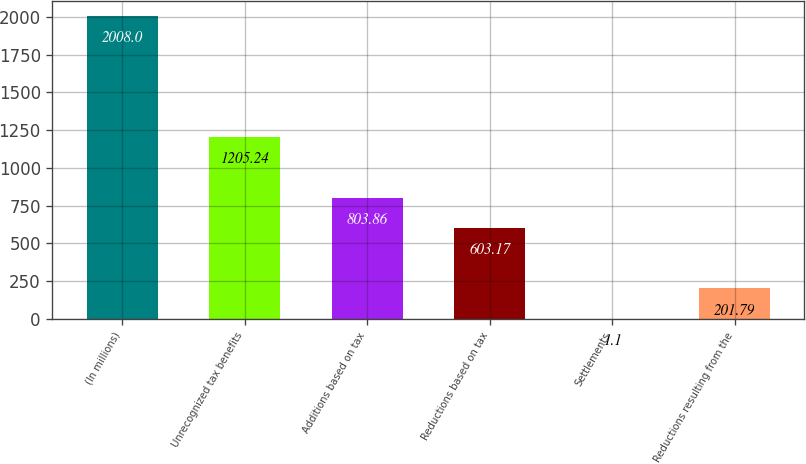Convert chart. <chart><loc_0><loc_0><loc_500><loc_500><bar_chart><fcel>(In millions)<fcel>Unrecognized tax benefits<fcel>Additions based on tax<fcel>Reductions based on tax<fcel>Settlements<fcel>Reductions resulting from the<nl><fcel>2008<fcel>1205.24<fcel>803.86<fcel>603.17<fcel>1.1<fcel>201.79<nl></chart> 